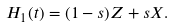Convert formula to latex. <formula><loc_0><loc_0><loc_500><loc_500>H _ { 1 } ( t ) = ( 1 - s ) Z + s X .</formula> 